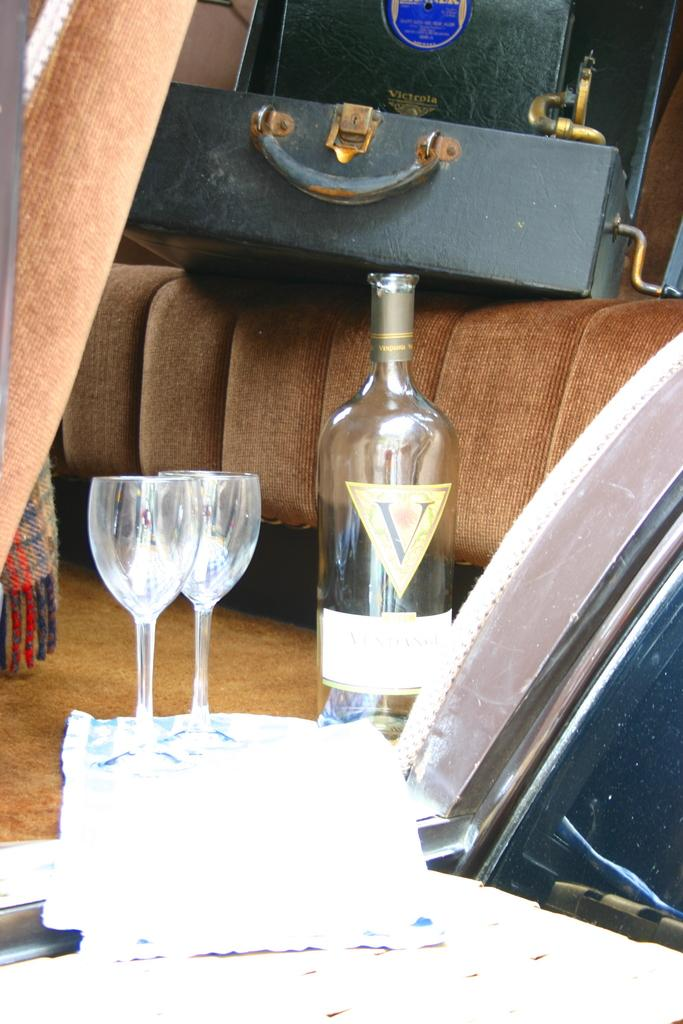What is one object that can be seen in the image? There is a bottle in the image. How many glasses are visible in the image? There are two glasses in the image. Where is the suitcase located in the image? The suitcase is on a sofa in the image. What type of item is made of paper in the image? There is a paper in the image. Can you see any snow in the image? There is no snow present in the image. Is there a beetle crawling on the suitcase in the image? There is no beetle visible in the image. 